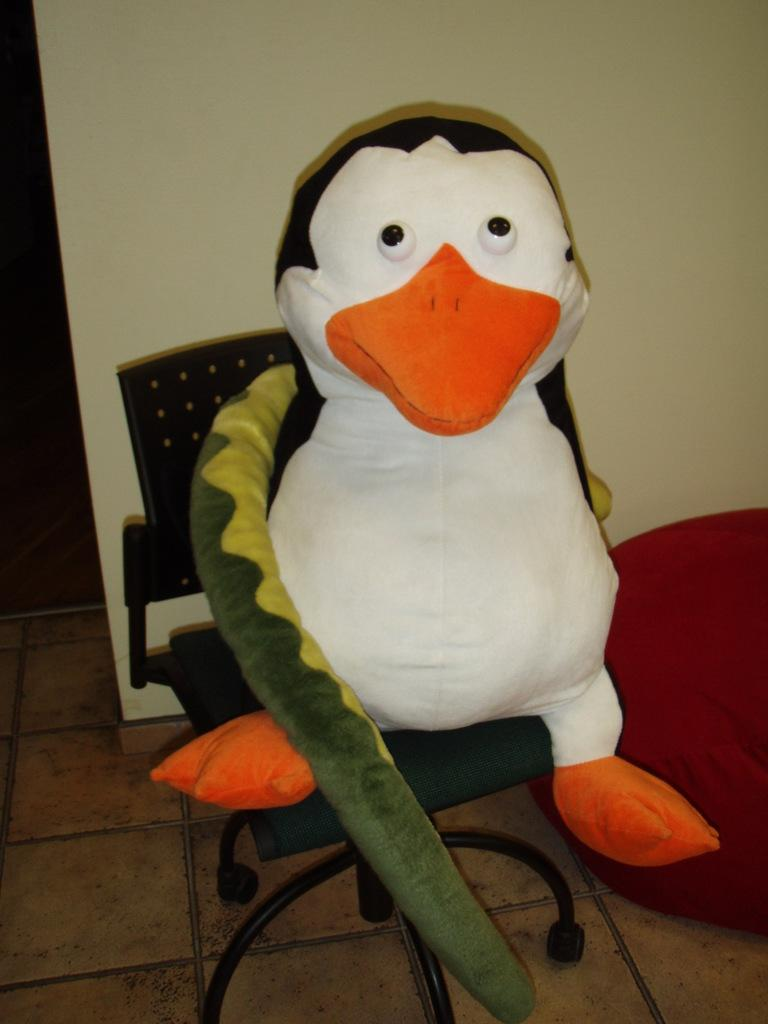What is the main subject in the center of the image? There is a toy in the center of the image. Where is the toy located? The toy is on a chair. What else can be seen on the right side of the image? There is a cloth on the right side of the image. How much does the mask weigh in the image? There is no mask present in the image, so it is not possible to determine its weight. 